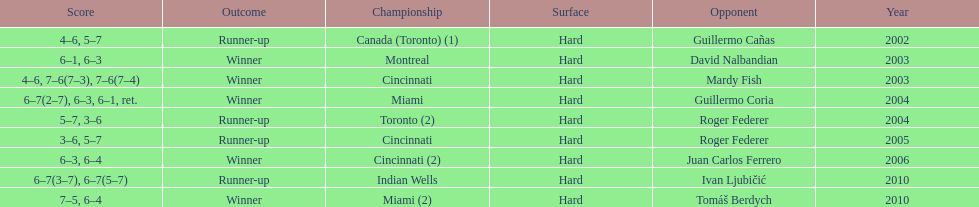How many times was the championship in miami? 2. 